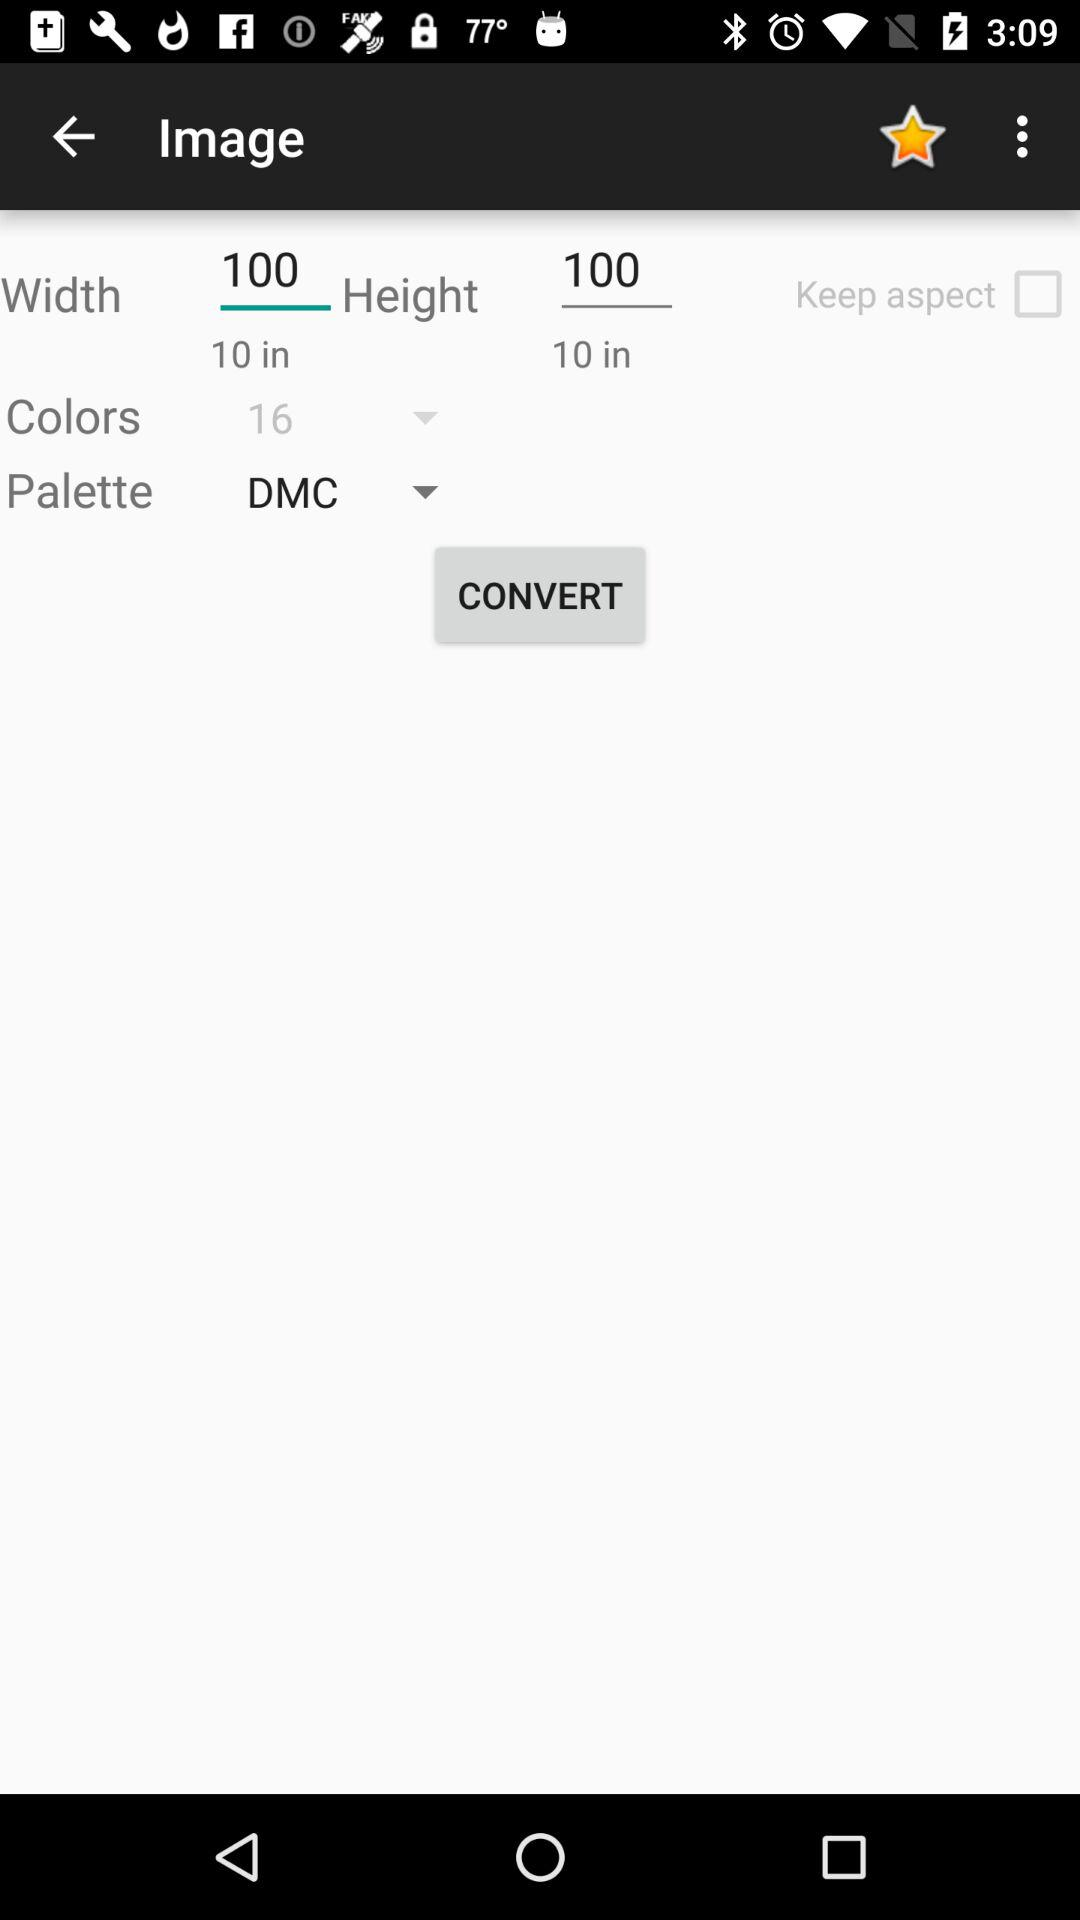What is the entered height? The entered height is 100. 